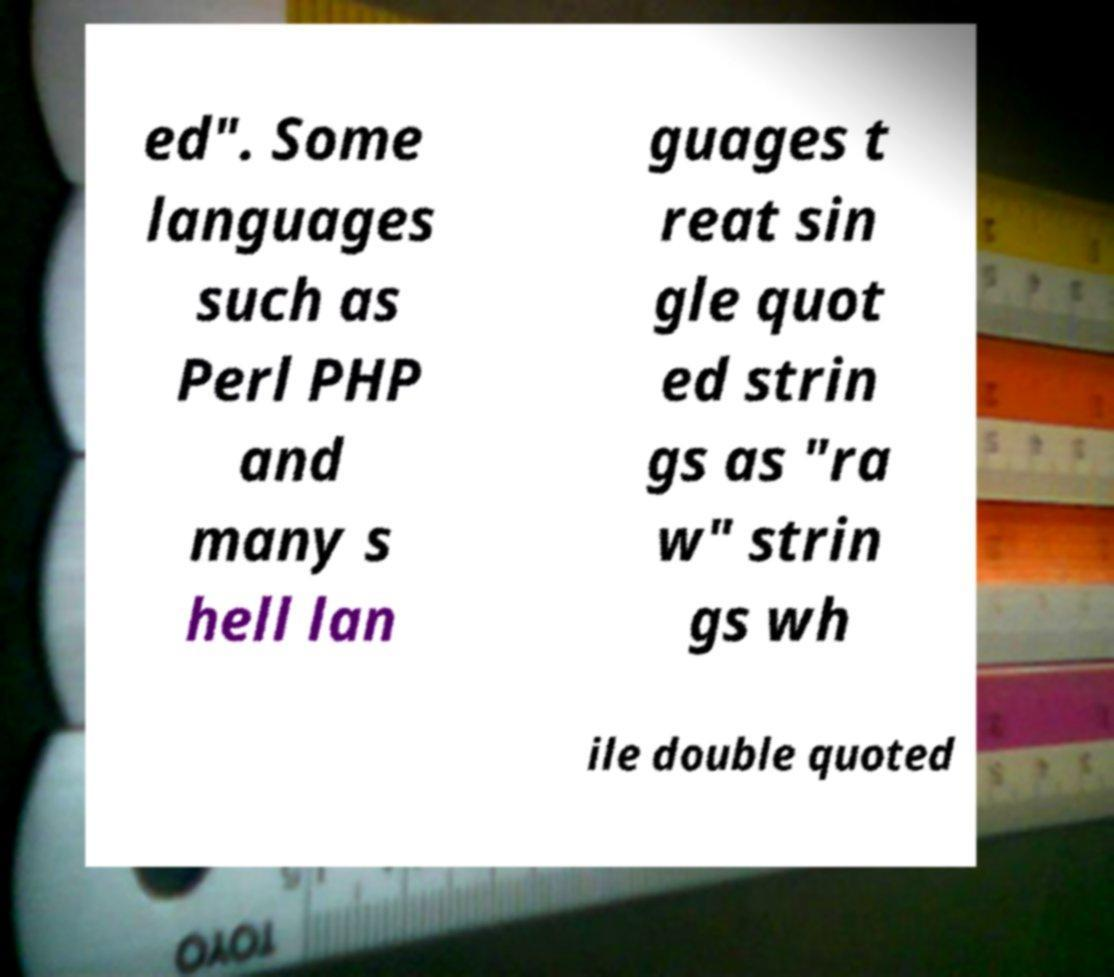Please identify and transcribe the text found in this image. ed". Some languages such as Perl PHP and many s hell lan guages t reat sin gle quot ed strin gs as "ra w" strin gs wh ile double quoted 